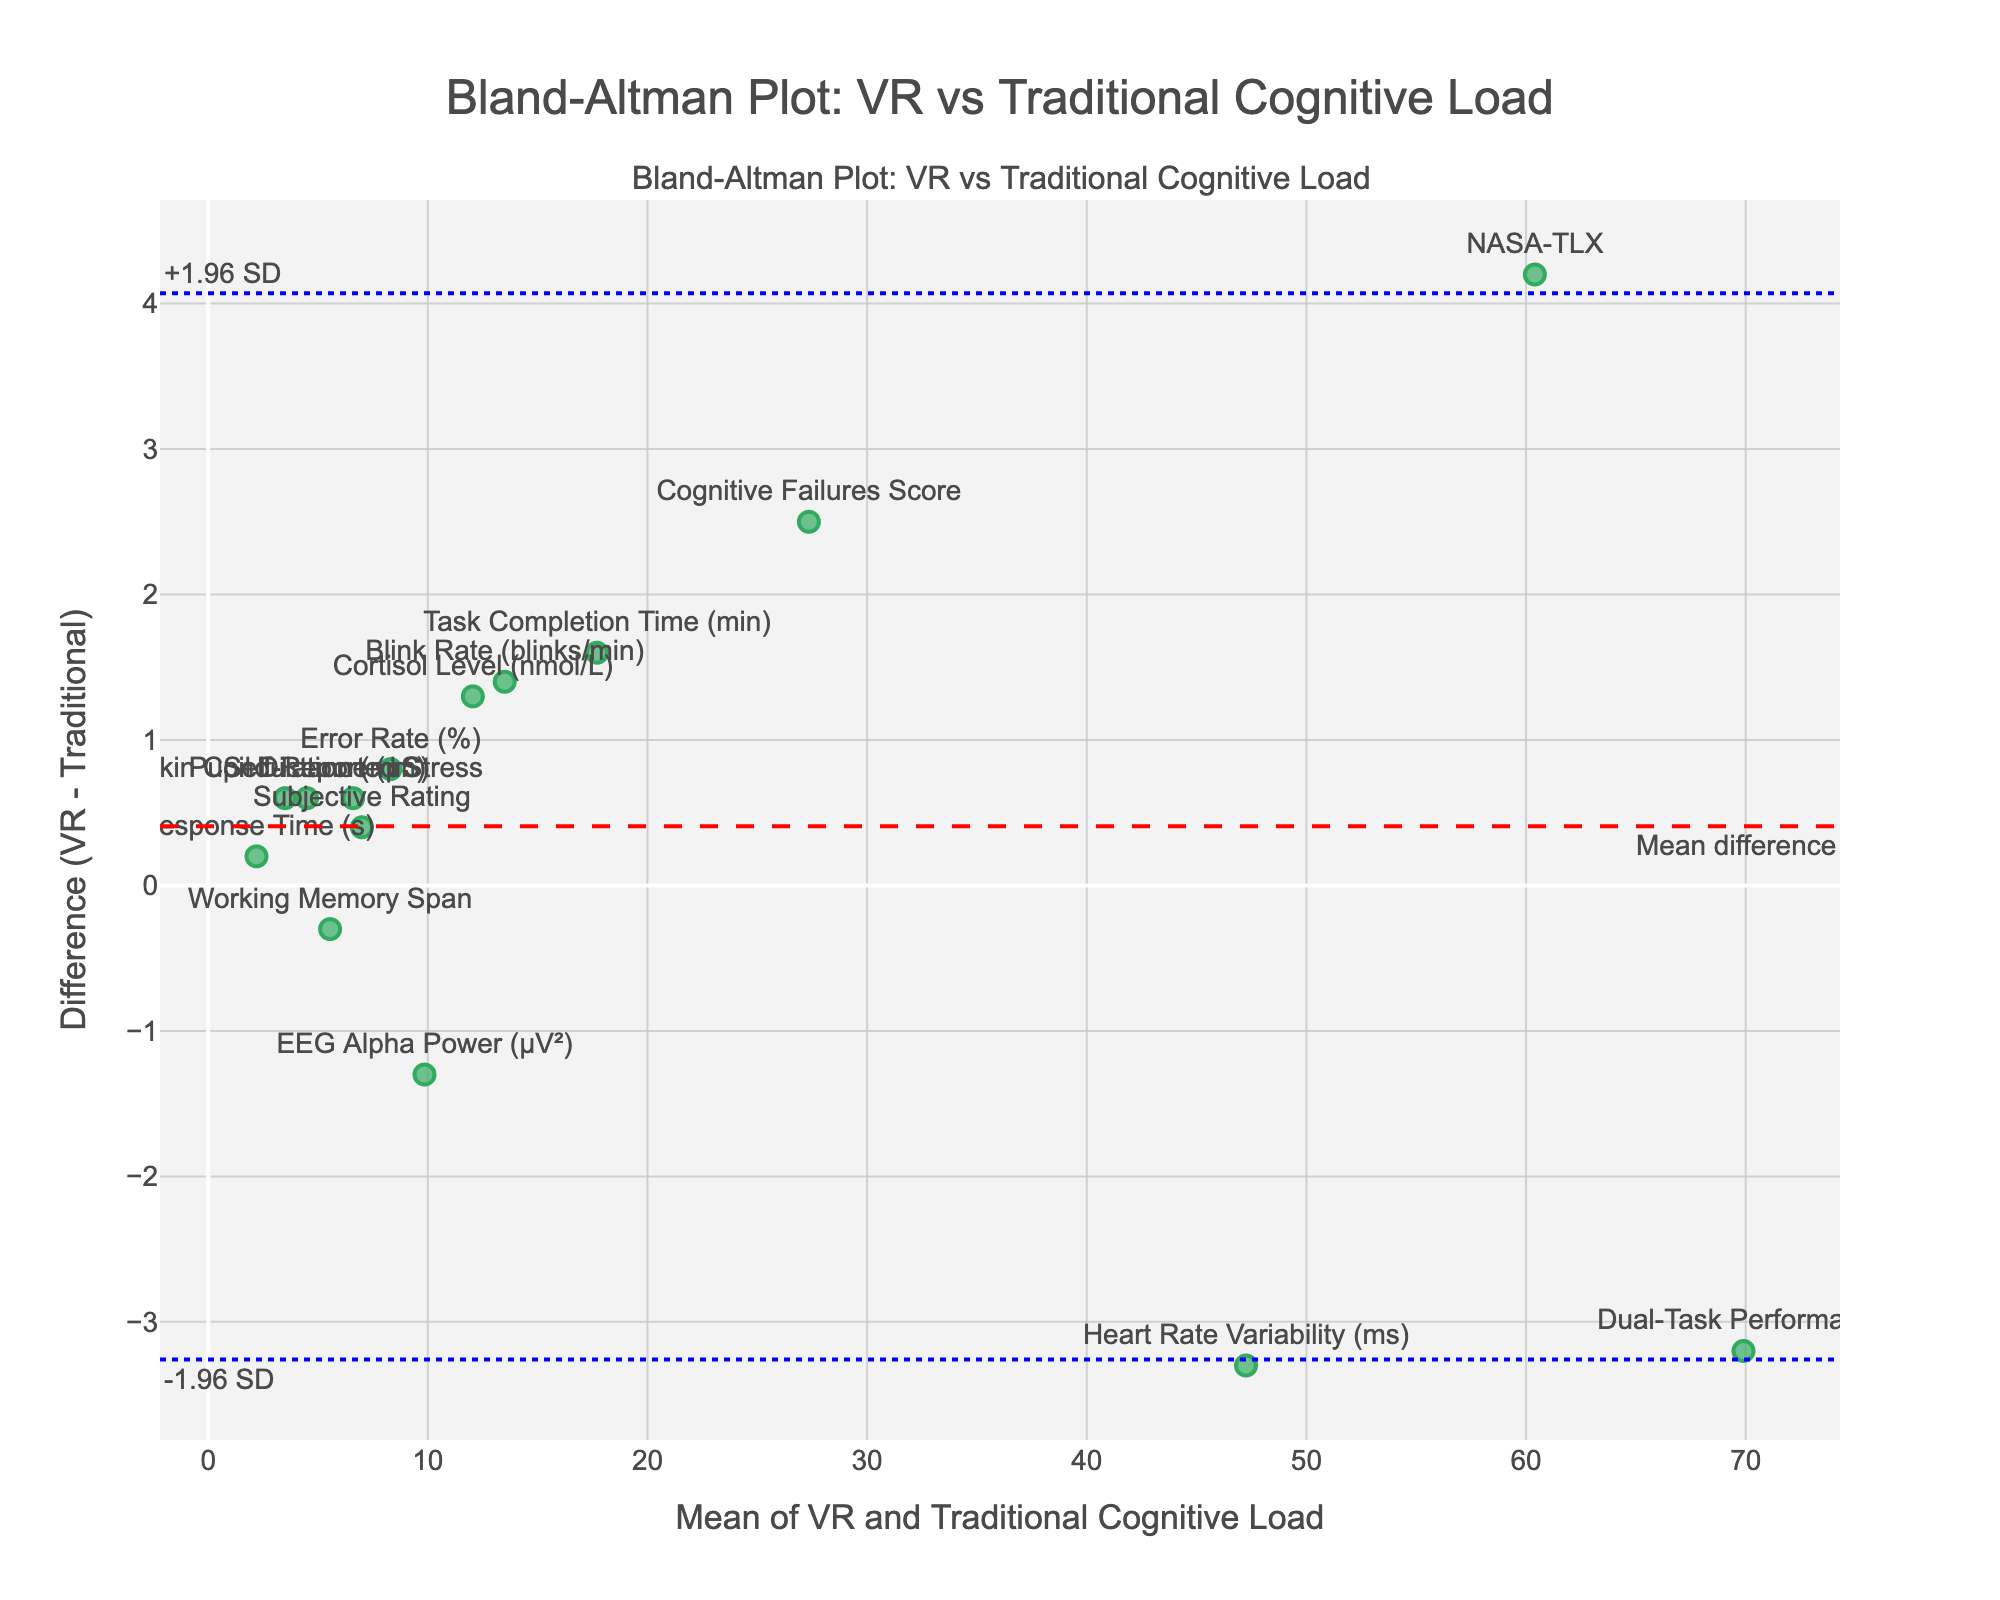what is the title of the plot? The title is the highest text on the plot, usually centered and prominent.
Answer: Bland-Altman Plot: VR vs Traditional Cognitive Load How many data points are displayed in the Bland-Altman plot? Count the number of markers or unique methods labeled in the plot.
Answer: 15 What does the red dashed line in the Bland-Altman plot represent? It is labeled and positioned differently from the others. Identify its meaning based on standard labeling conventions in such plots.
Answer: Mean difference What are the values of the limits of agreement shown by the blue dotted lines? Read the annotated values on the blue dotted horizontal lines.
Answer: -1.96 SD, +1.96 SD Which method shows the largest positive difference between VR and traditional cognitive loads? Find the marker furthest above the x-axis (difference axis) and read the label.
Answer: Dual-Task Performance Which method has the smallest mean cognitive load between VR and traditional tasks? Find the marker located furthest to the left on the x-axis and read the label.
Answer: Pupil Dilation (mm) What is the average mean cognitive load value of Skin Conductance (μS) and Heart Rate Variability (ms)? Calculate the mean of the two values shown on the x-axis for these methods: (3.5+47.25)/2 = 25.375
Answer: 25.375 Compare the cognitive load measured by EEG Alpha Power (μV²) and Cortisol Level (nmol/L). Which has a greater difference and by how much? Measure the distance each is positioned from the x-axis and calculate the absolute difference. EEG Alpha Power: -1.3, Cortisol Level: 1.3, the greater difference is the Cortisol Level by 1.3 units
Answer: Cortisol Level, 1.3 Is the cognitive load from VR tasks typically higher or lower than traditional tasks based on this plot? Observe the general trend of markers' positions relative to the x-axis.
Answer: Higher 